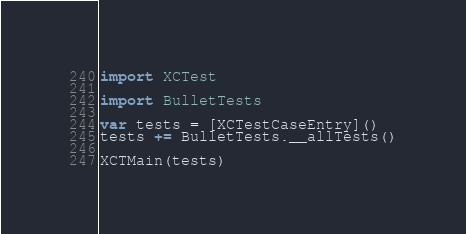Convert code to text. <code><loc_0><loc_0><loc_500><loc_500><_Swift_>import XCTest

import BulletTests

var tests = [XCTestCaseEntry]()
tests += BulletTests.__allTests()

XCTMain(tests)
</code> 